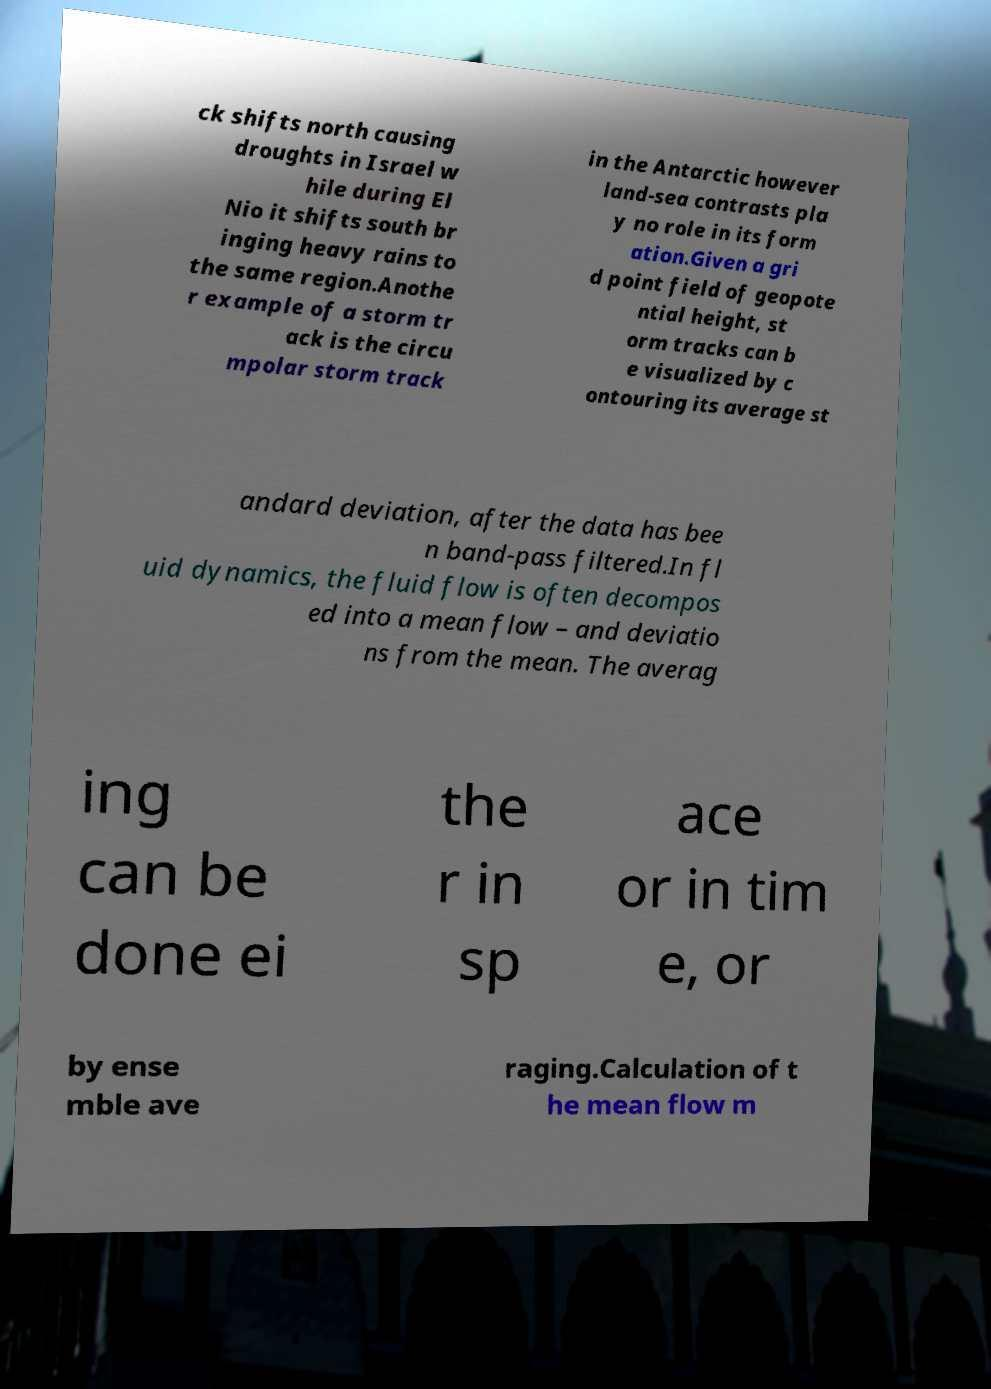Could you extract and type out the text from this image? ck shifts north causing droughts in Israel w hile during El Nio it shifts south br inging heavy rains to the same region.Anothe r example of a storm tr ack is the circu mpolar storm track in the Antarctic however land-sea contrasts pla y no role in its form ation.Given a gri d point field of geopote ntial height, st orm tracks can b e visualized by c ontouring its average st andard deviation, after the data has bee n band-pass filtered.In fl uid dynamics, the fluid flow is often decompos ed into a mean flow – and deviatio ns from the mean. The averag ing can be done ei the r in sp ace or in tim e, or by ense mble ave raging.Calculation of t he mean flow m 